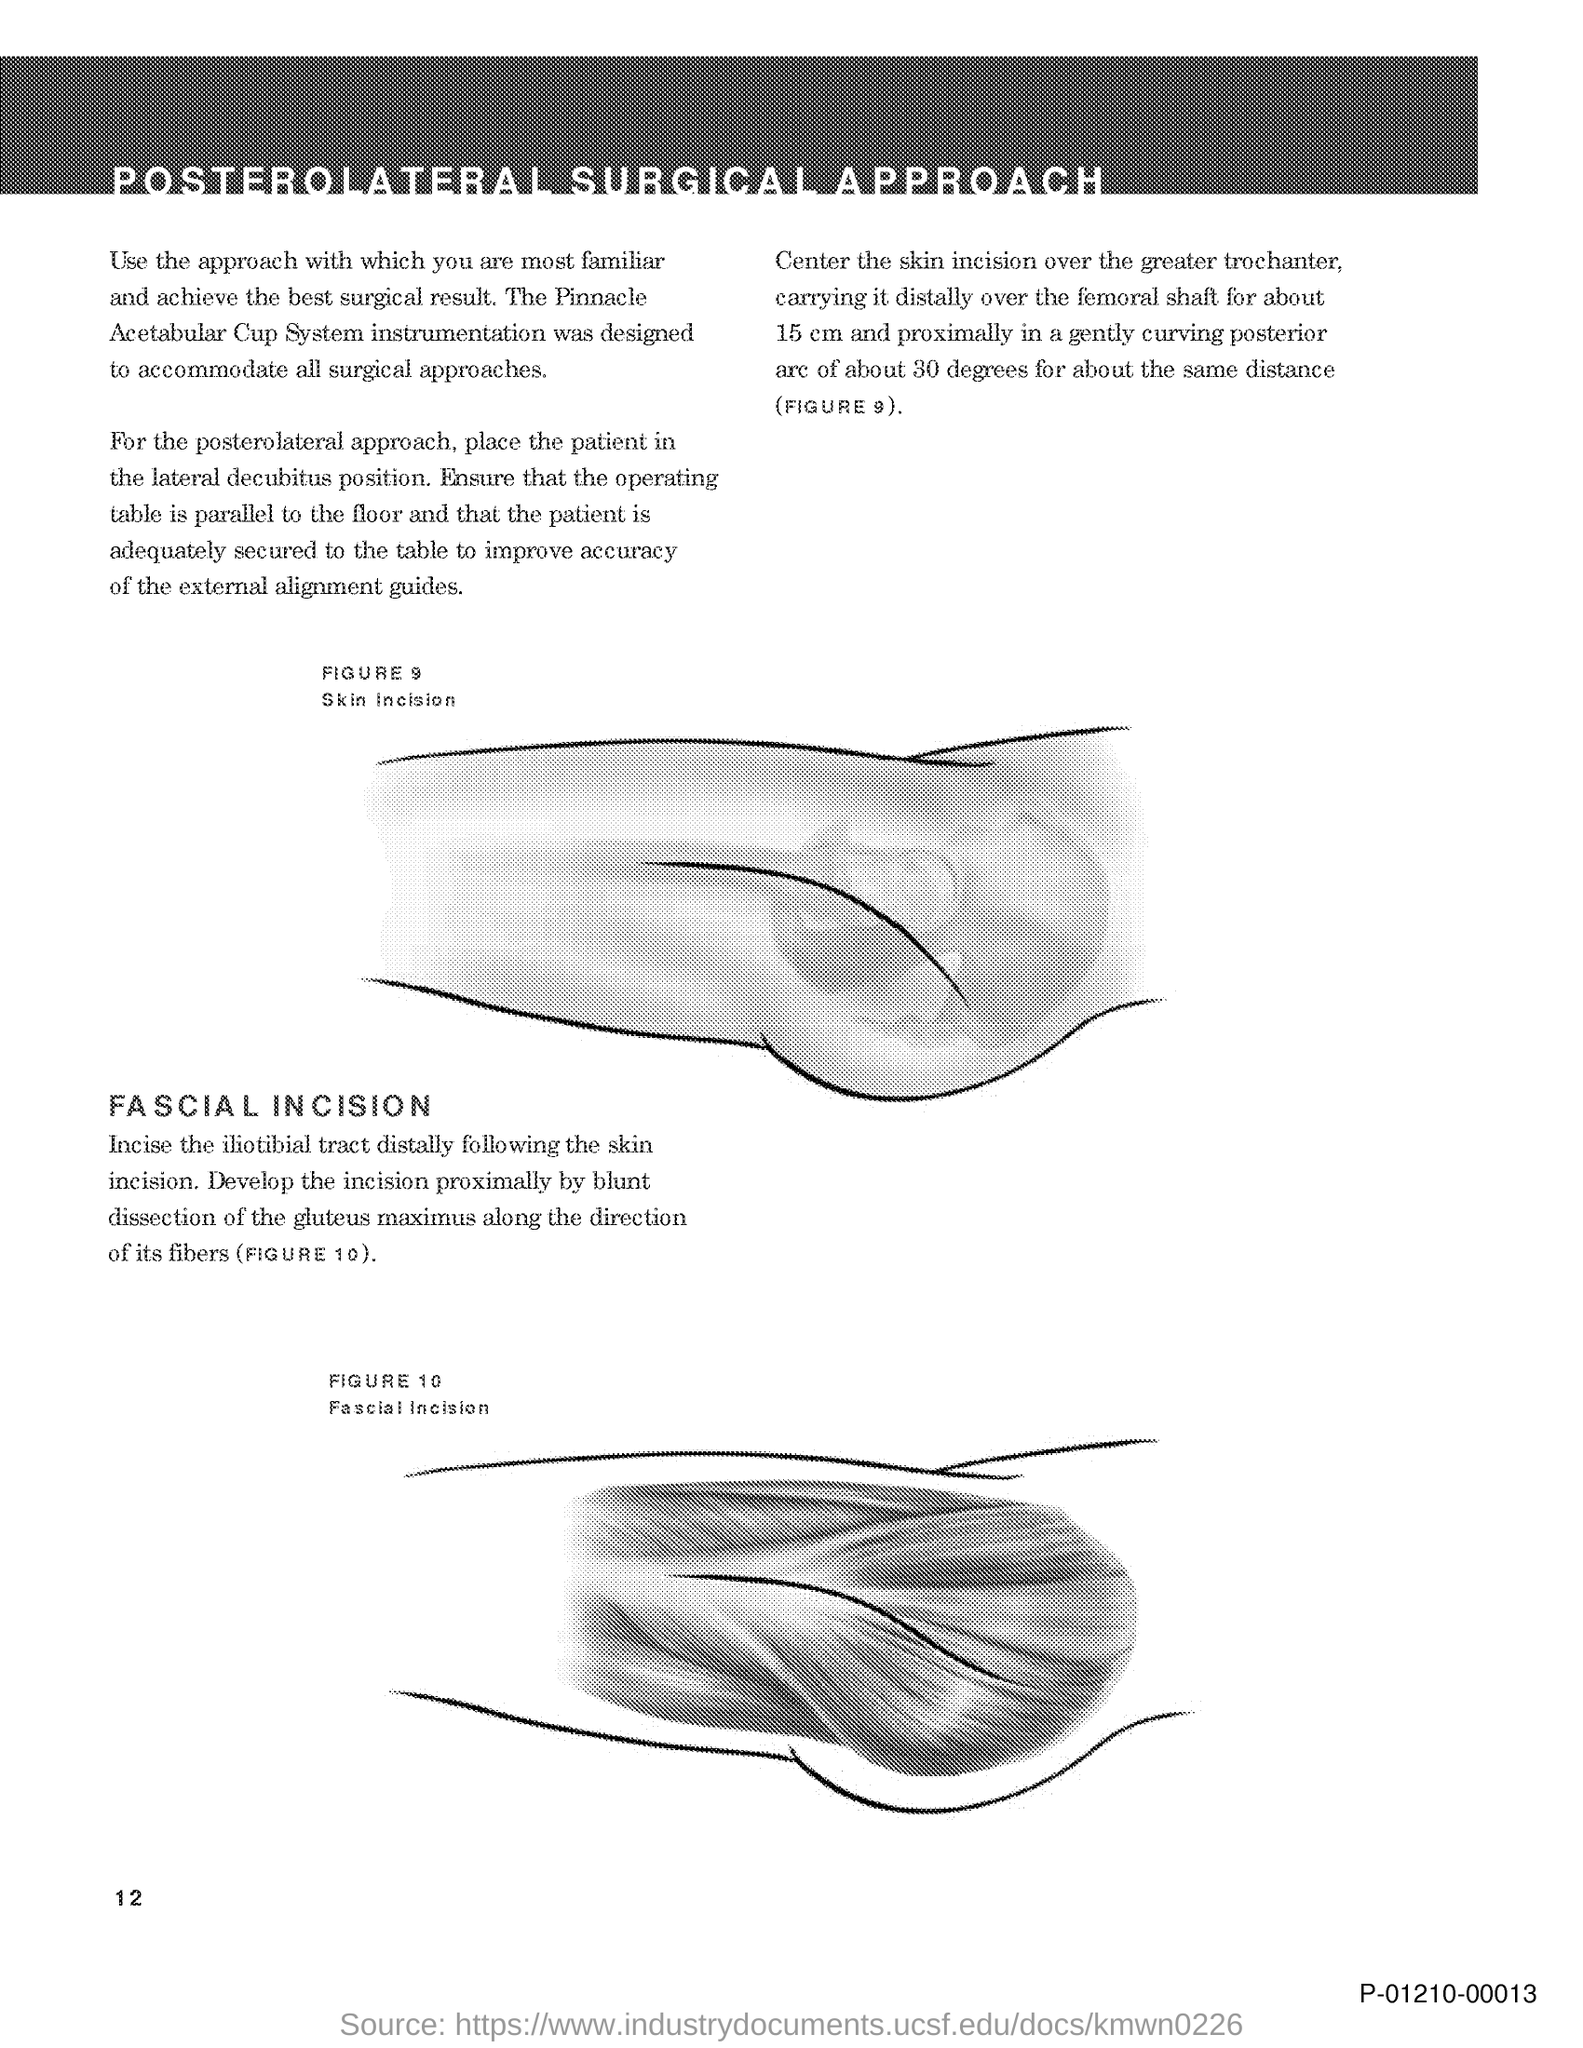What is the title of the document?
Your answer should be very brief. Posterolateral Surgical Approach. What is the Page Number?
Provide a short and direct response. 12. 